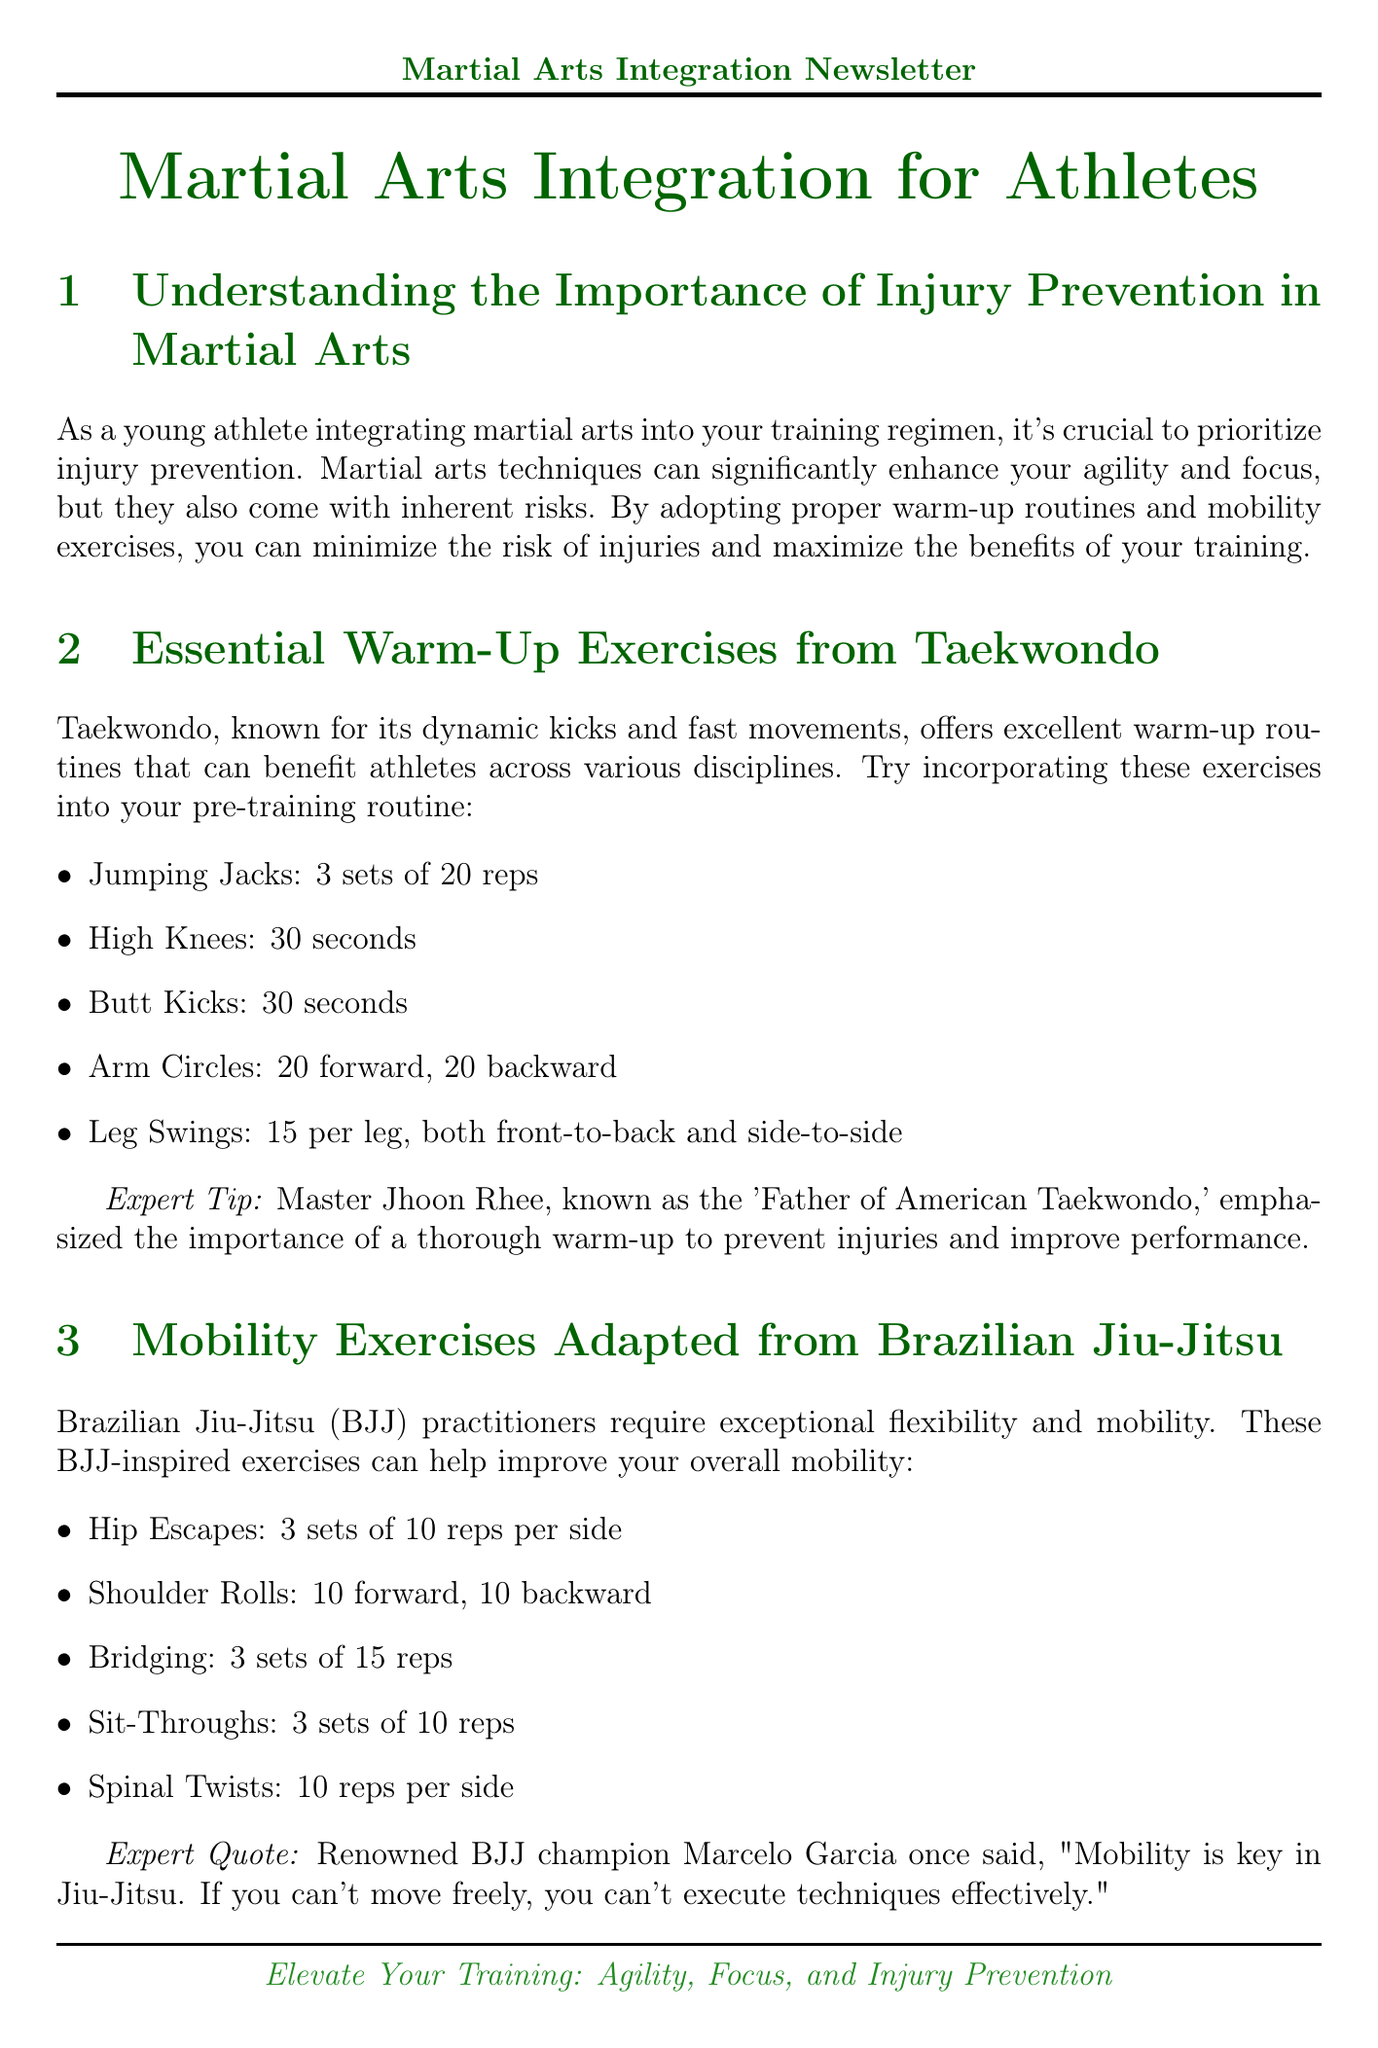what is the title of the newsletter? The title is prominently displayed at the top of the document and indicates the purpose of the content.
Answer: Martial Arts Integration for Athletes who is referred to as the 'Father of American Taekwondo'? This figure is mentioned in the warm-up section as an expert who emphasizes the importance of warm-ups.
Answer: Master Jhoon Rhee how many sets of "Hip Escapes" are recommended? This exercise is listed under the mobility exercises adapted from Brazilian Jiu-Jitsu section, specifying the number of sets.
Answer: 3 sets what hydration recommendation is made in the Muay Thai injury prevention strategies? The content details the importance of hydration and provides a specific daily requirement.
Answer: 3 liters which martial art is associated with the quote about mobility being key? This quote is attributed to a renowned champion and is found in the section discussing BJJ exercises.
Answer: Brazilian Jiu-Jitsu what common exercise is suggested for core stabilization? This exercise is mentioned under injury prevention strategies from Muay Thai and is well-known in fitness routines.
Answer: Planks how long should deep breathing exercises be performed for during the cool-down? This specific duration is stated in the recovery techniques section related to Aikido.
Answer: 5 minutes what is one benefit of proper nutrition mentioned in the newsletter? The document states a specific outcome related to nutrition and athletes, emphasizing health benefits.
Answer: Reduce injury risk 